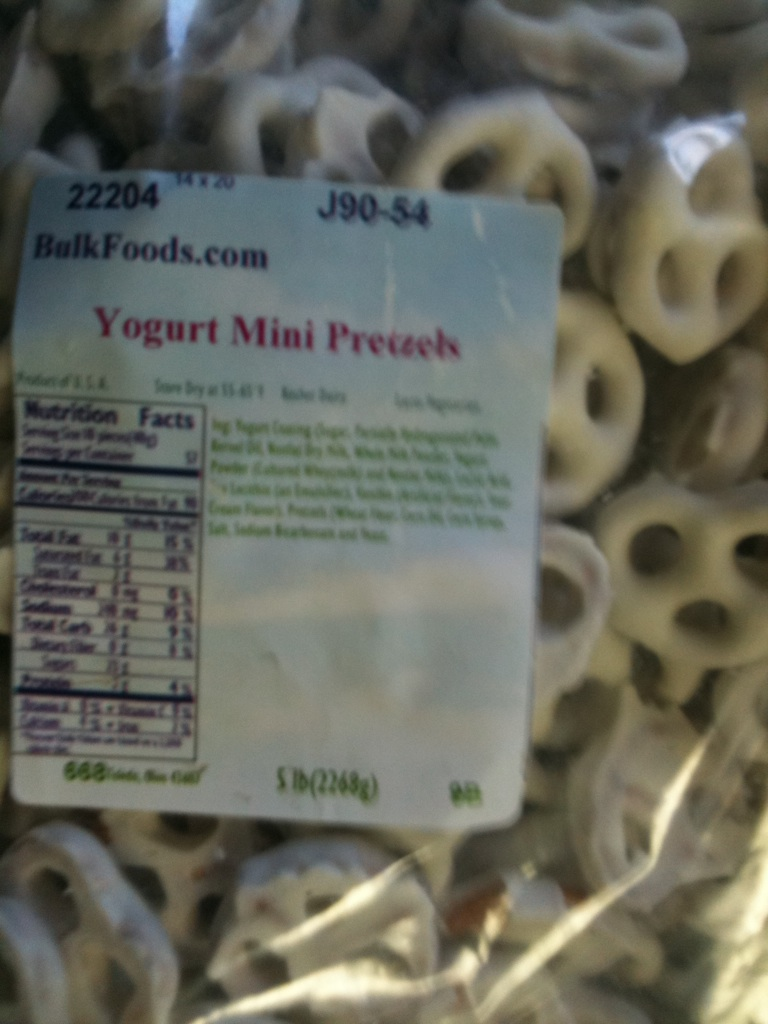How would these pretzels be used in a party setting? Short Response:
Yogurt Mini Pretzels make an excellent snack for a party; simply place them in decorative bowls around the room for guests to enjoy.

Long Response:
For a more elaborate party setting, you can create a 'Pretzel Bar.' Arrange these Yogurt Mini Pretzels alongside other flavored pretzels, dips like chocolate fondue, peanut butter, and various toppings such as crushed nuts and sprinkles. This interactive snack station will not only be a hit but also provide a fun activity for guests to customize their own treats. 